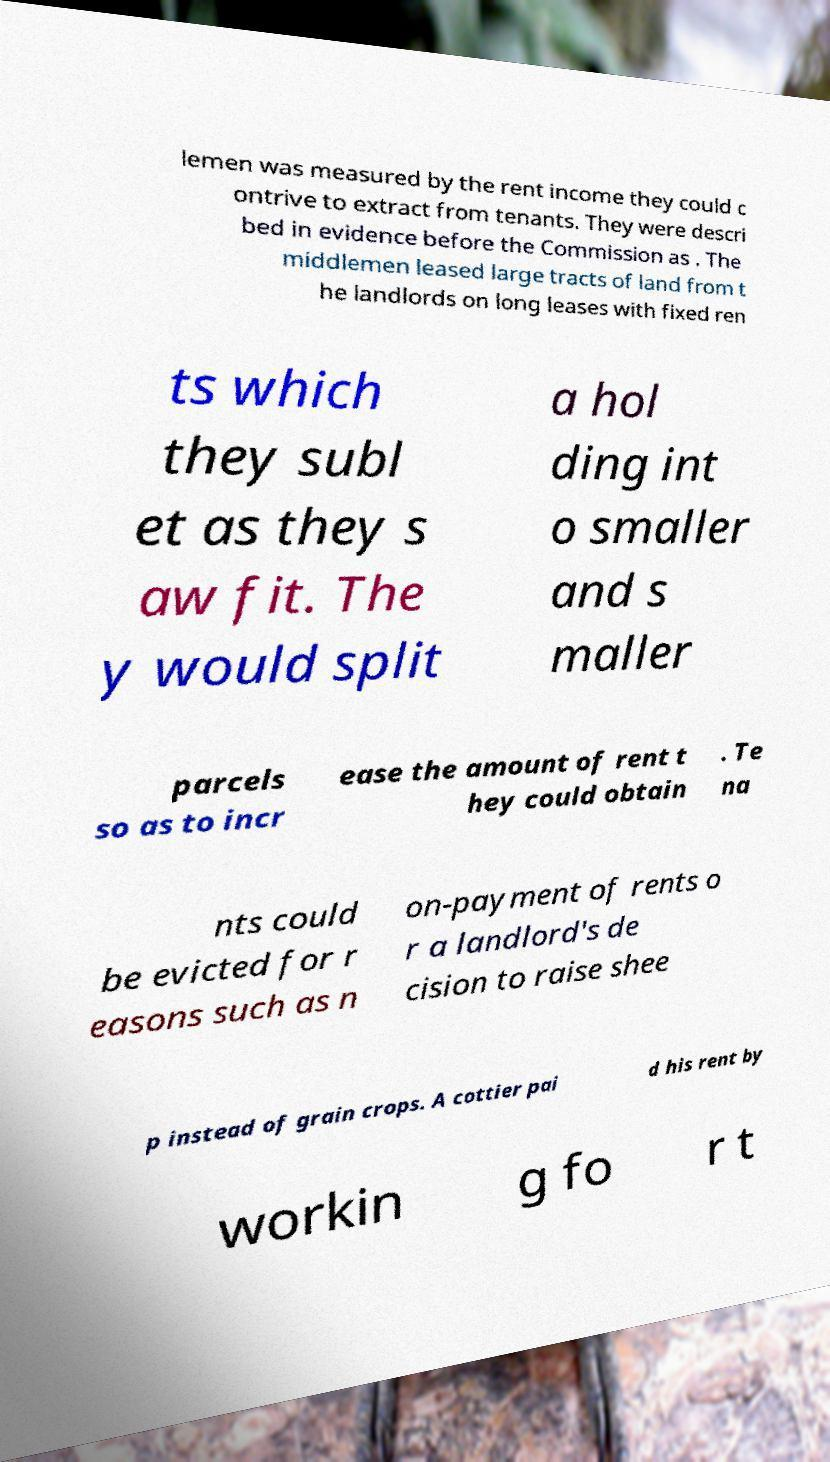Can you read and provide the text displayed in the image?This photo seems to have some interesting text. Can you extract and type it out for me? lemen was measured by the rent income they could c ontrive to extract from tenants. They were descri bed in evidence before the Commission as . The middlemen leased large tracts of land from t he landlords on long leases with fixed ren ts which they subl et as they s aw fit. The y would split a hol ding int o smaller and s maller parcels so as to incr ease the amount of rent t hey could obtain . Te na nts could be evicted for r easons such as n on-payment of rents o r a landlord's de cision to raise shee p instead of grain crops. A cottier pai d his rent by workin g fo r t 